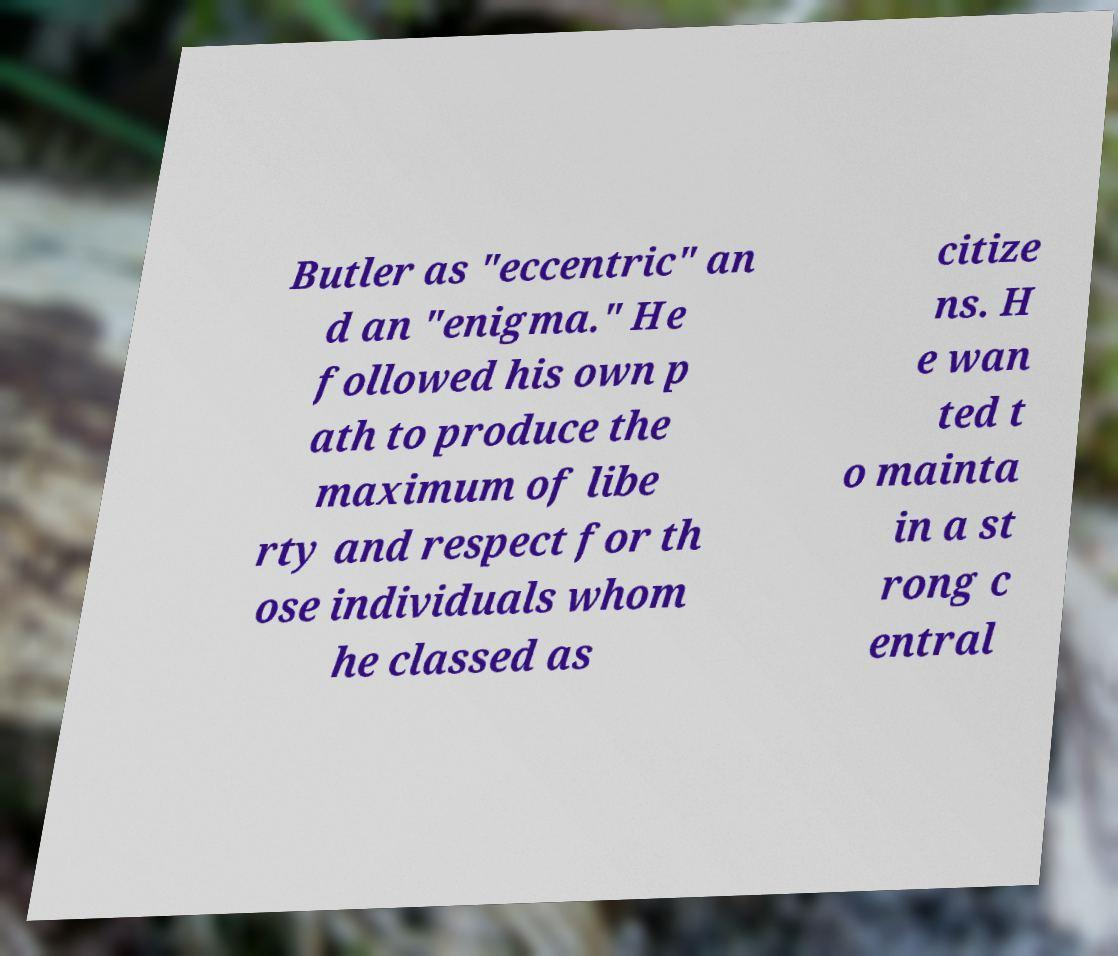For documentation purposes, I need the text within this image transcribed. Could you provide that? Butler as "eccentric" an d an "enigma." He followed his own p ath to produce the maximum of libe rty and respect for th ose individuals whom he classed as citize ns. H e wan ted t o mainta in a st rong c entral 